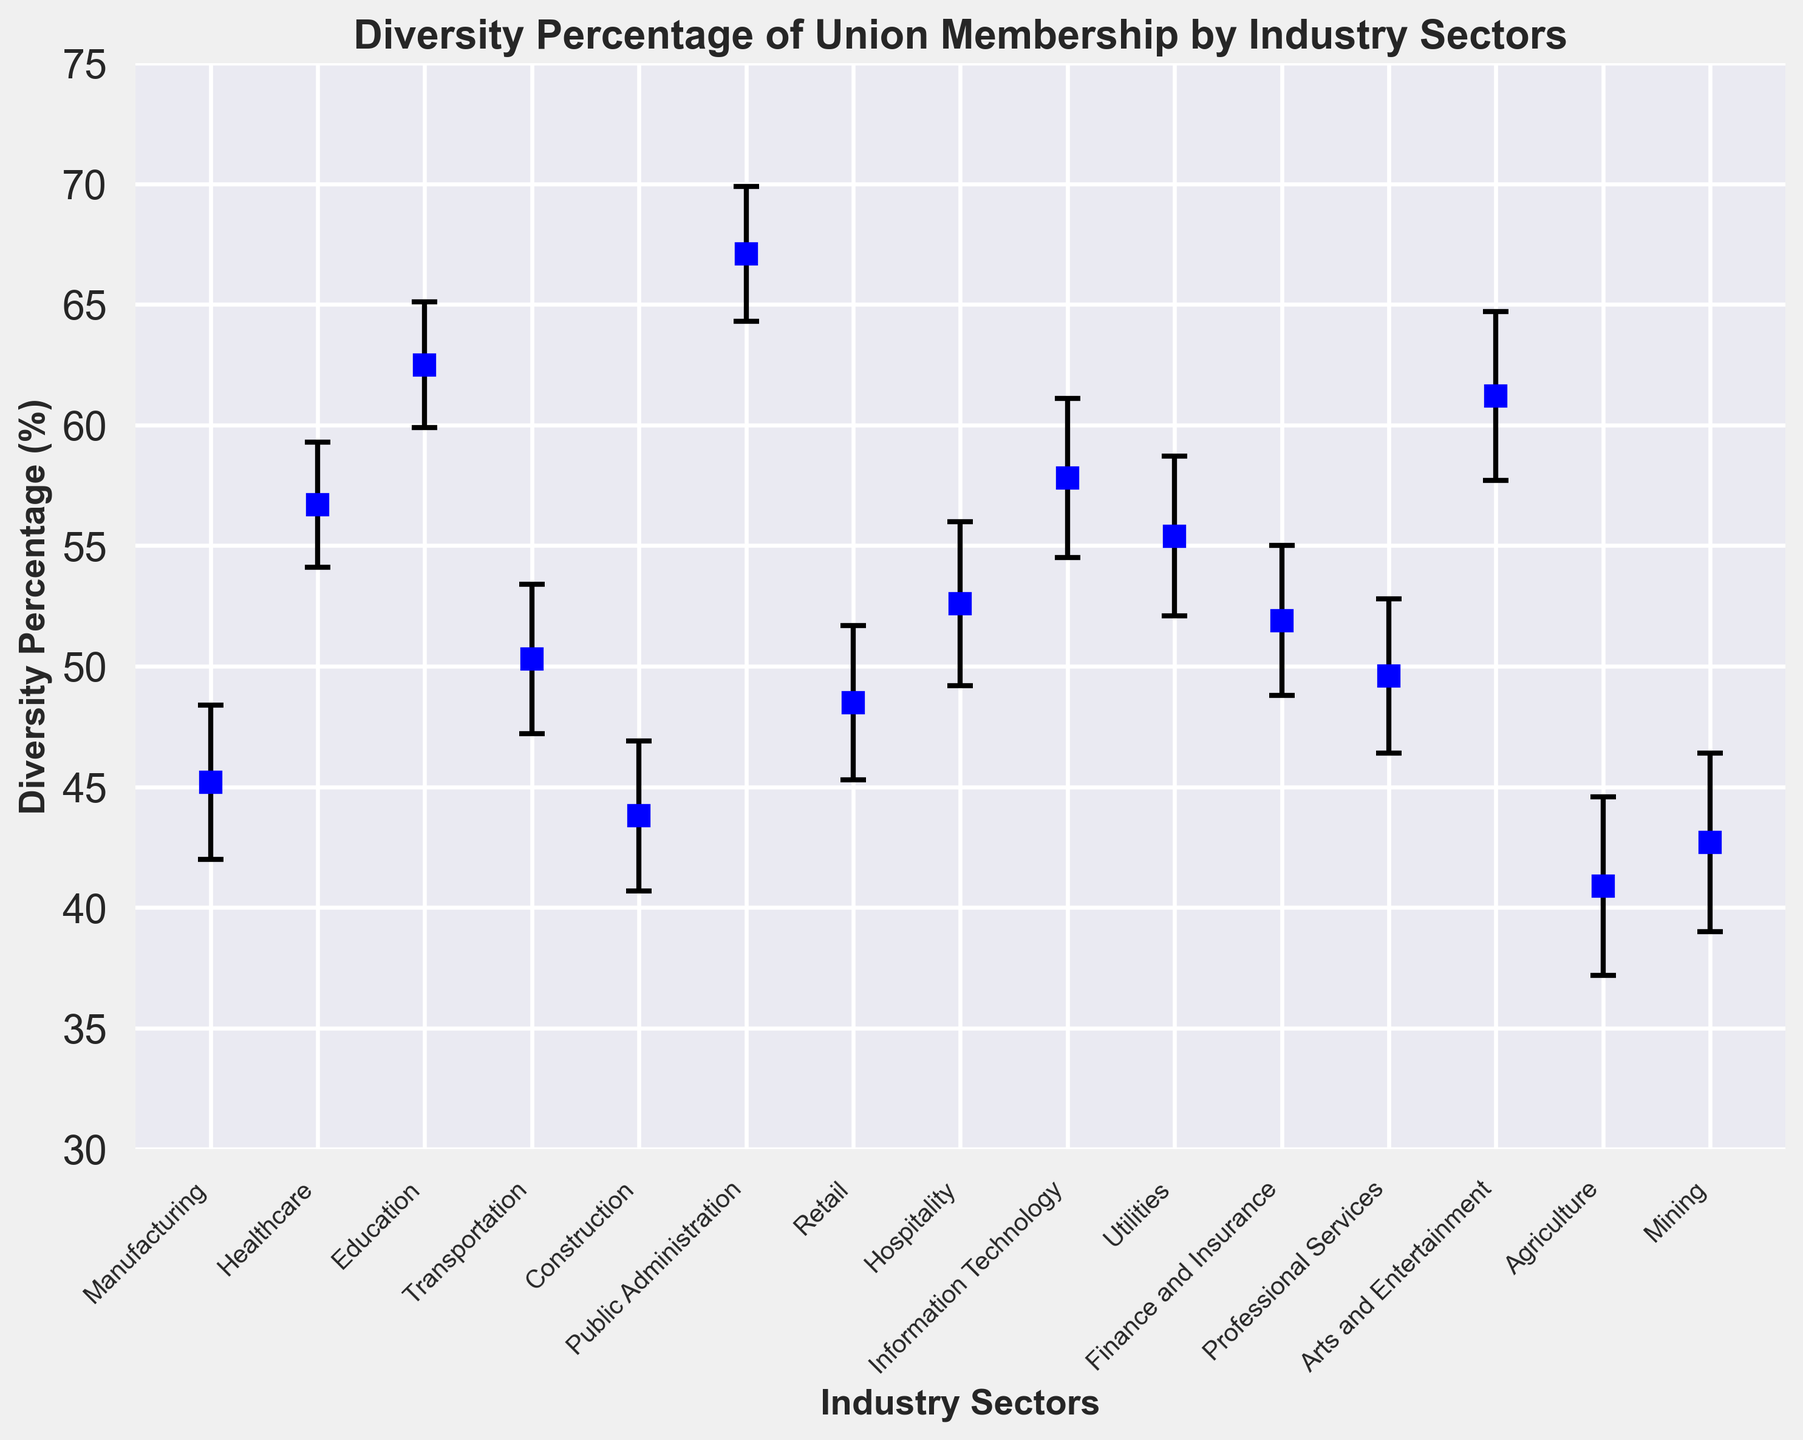What industry sector has the highest diversity percentage? By looking at the plot, the sector with the highest point on the y-axis will have the highest diversity percentage. Public Administration has the highest point.
Answer: Public Administration Which industry sector has the lowest diversity percentage? By observing the plot, the sector with the lowest point on the y-axis has the lowest diversity percentage. Agriculture has the lowest point.
Answer: Agriculture What is the difference in diversity percentage between Manufacturing and Information Technology? First, note the diversity percentages for Manufacturing (45.2%) and Information Technology (57.8%). Subtract the diversity percentage of Manufacturing from that of Information Technology: 57.8 - 45.2.
Answer: 12.6 Does the Agriculture sector have a lower diversity percentage than the Construction sector? Refer to the diversity percentages: Agriculture has 40.9% and Construction has 43.8%. Since 40.9% is less than 43.8%, Agriculture has a lower diversity percentage than Construction.
Answer: Yes Which sector has a greater confidence interval range: Healthcare or Arts and Entertainment? To find the confidence interval range, subtract the lower bound from the upper bound for both sectors. For Healthcare: 59.3 - 54.1 = 5.2. For Arts and Entertainment: 64.7 - 57.7 = 7.0. Compare the ranges: 7.0 is greater than 5.2.
Answer: Arts and Entertainment Are there any sectors where the diversity percentage is above 60%? Check the y-axis values of each point; Public Administration, Education, and Arts and Entertainment have points above 60% on the y-axis.
Answer: Yes Do Finance and Insurance and Professional Services have nearly the same diversity percentage? Look at the plot to check the proximity of their points on the y-axis: Finance and Insurance is at 51.9% and Professional Services is at 49.6%. The difference is 2.3%, which is relatively close.
Answer: Yes Is there any sector that has a confidence interval entirely above 50%? Check sectors where both the lower and upper bounds of the confidence intervals are above 50%. Public Administration, Education, Arts and Entertainment, Healthcare, and Information Technology meet this criterion.
Answer: Yes What is the average diversity percentage of the top three sectors with the highest diversity percentages? Identify the top three sectors: Public Administration (67.1%), Education (62.5%), and Arts and Entertainment (61.2%). Calculate their average: (67.1 + 62.5 + 61.2) / 3.
Answer: 63.6 